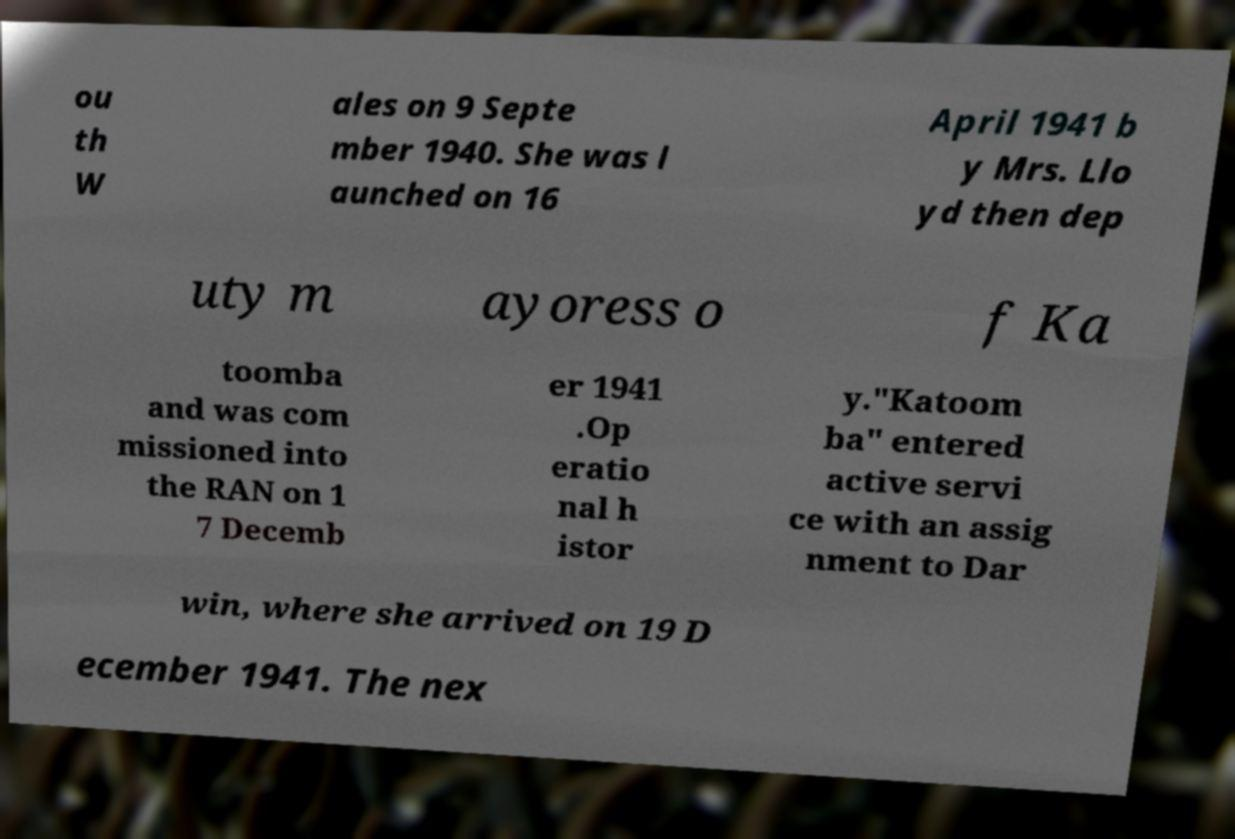I need the written content from this picture converted into text. Can you do that? ou th W ales on 9 Septe mber 1940. She was l aunched on 16 April 1941 b y Mrs. Llo yd then dep uty m ayoress o f Ka toomba and was com missioned into the RAN on 1 7 Decemb er 1941 .Op eratio nal h istor y."Katoom ba" entered active servi ce with an assig nment to Dar win, where she arrived on 19 D ecember 1941. The nex 